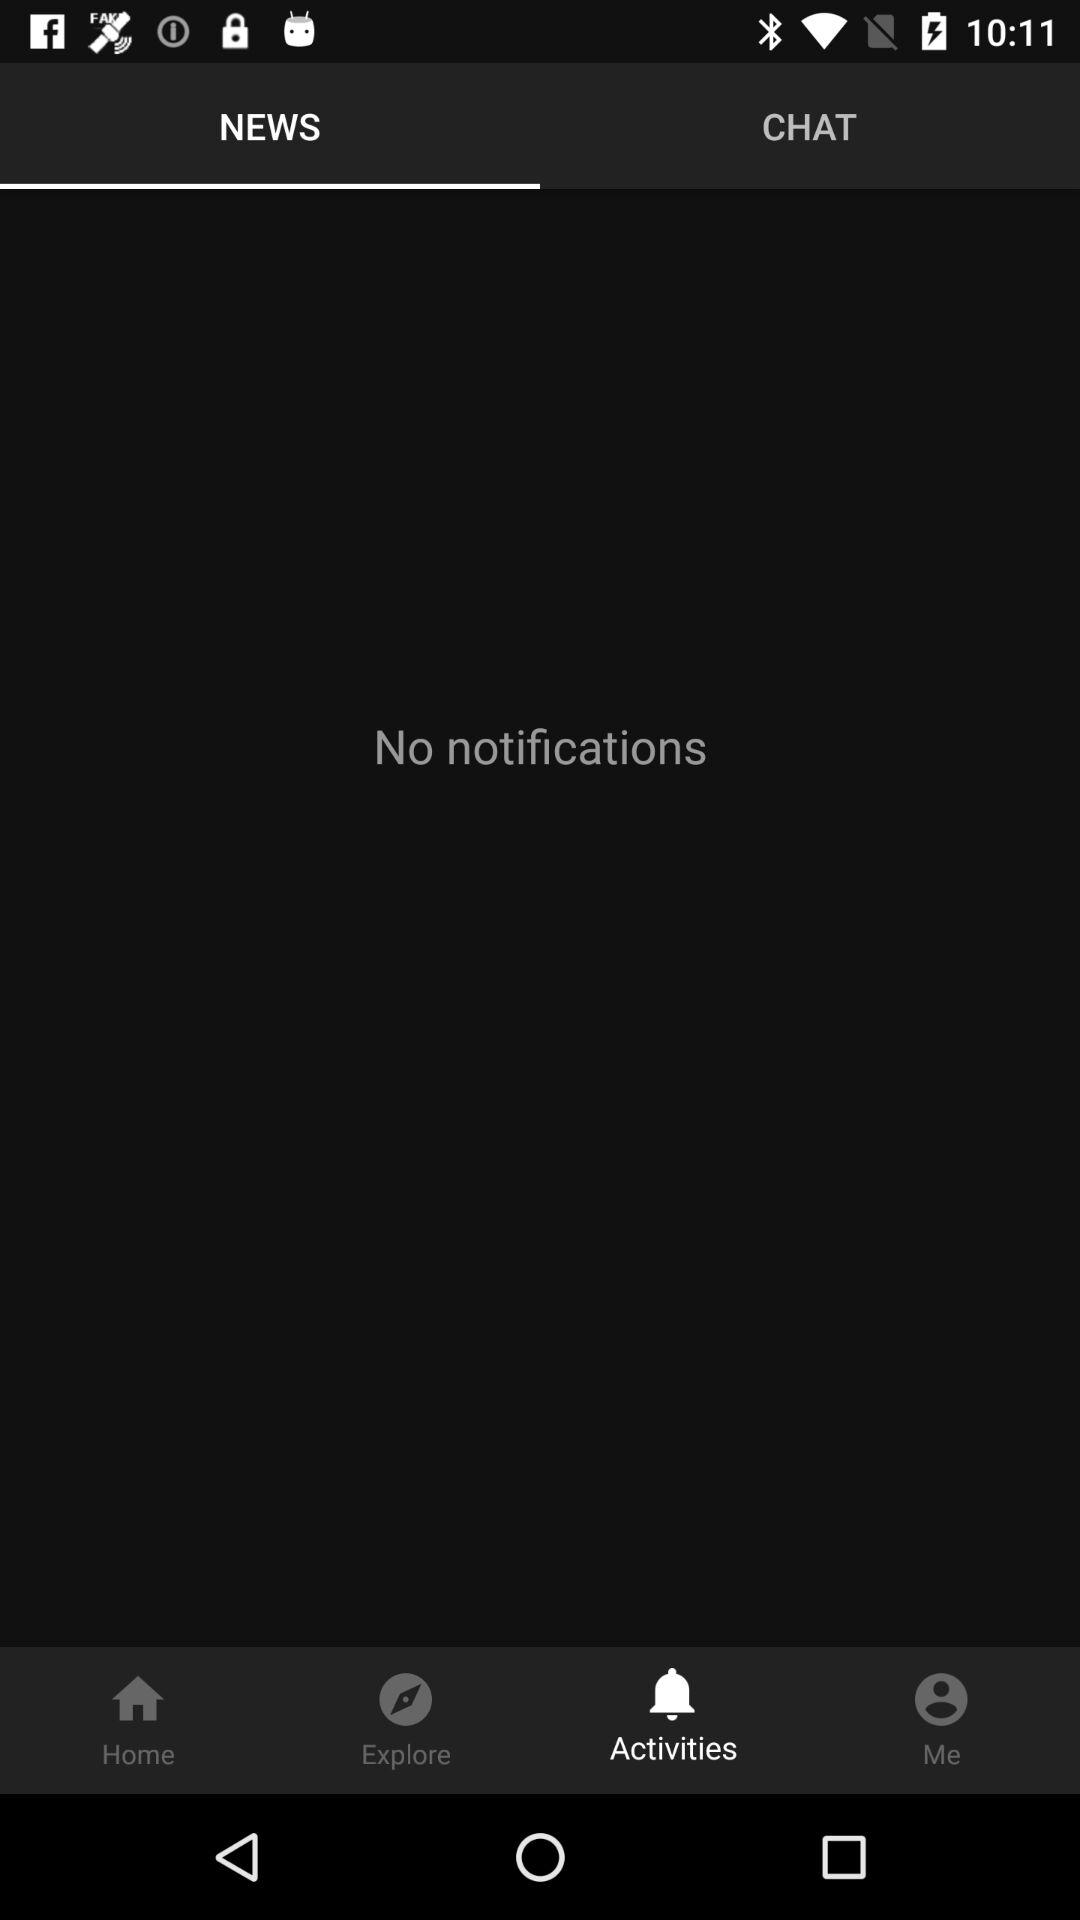How many notifications are there?
Answer the question using a single word or phrase. 0 